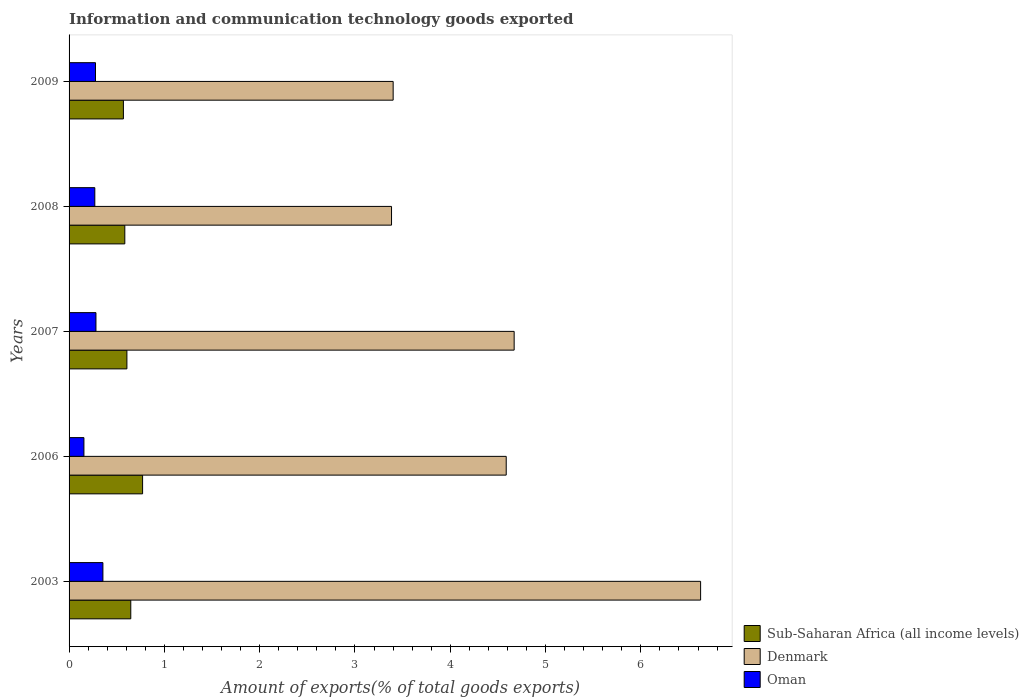How many groups of bars are there?
Provide a short and direct response. 5. How many bars are there on the 5th tick from the top?
Provide a succinct answer. 3. In how many cases, is the number of bars for a given year not equal to the number of legend labels?
Provide a succinct answer. 0. What is the amount of goods exported in Oman in 2006?
Keep it short and to the point. 0.16. Across all years, what is the maximum amount of goods exported in Oman?
Provide a succinct answer. 0.36. Across all years, what is the minimum amount of goods exported in Denmark?
Provide a short and direct response. 3.38. In which year was the amount of goods exported in Denmark minimum?
Offer a very short reply. 2008. What is the total amount of goods exported in Denmark in the graph?
Offer a very short reply. 22.67. What is the difference between the amount of goods exported in Oman in 2006 and that in 2008?
Your response must be concise. -0.11. What is the difference between the amount of goods exported in Sub-Saharan Africa (all income levels) in 2006 and the amount of goods exported in Oman in 2007?
Provide a succinct answer. 0.49. What is the average amount of goods exported in Denmark per year?
Keep it short and to the point. 4.53. In the year 2009, what is the difference between the amount of goods exported in Denmark and amount of goods exported in Sub-Saharan Africa (all income levels)?
Keep it short and to the point. 2.83. What is the ratio of the amount of goods exported in Sub-Saharan Africa (all income levels) in 2007 to that in 2008?
Provide a short and direct response. 1.04. Is the difference between the amount of goods exported in Denmark in 2003 and 2008 greater than the difference between the amount of goods exported in Sub-Saharan Africa (all income levels) in 2003 and 2008?
Ensure brevity in your answer.  Yes. What is the difference between the highest and the second highest amount of goods exported in Denmark?
Offer a very short reply. 1.96. What is the difference between the highest and the lowest amount of goods exported in Denmark?
Offer a very short reply. 3.24. In how many years, is the amount of goods exported in Oman greater than the average amount of goods exported in Oman taken over all years?
Keep it short and to the point. 4. Is the sum of the amount of goods exported in Oman in 2003 and 2007 greater than the maximum amount of goods exported in Denmark across all years?
Give a very brief answer. No. What does the 3rd bar from the top in 2007 represents?
Your response must be concise. Sub-Saharan Africa (all income levels). What does the 1st bar from the bottom in 2006 represents?
Your answer should be very brief. Sub-Saharan Africa (all income levels). Is it the case that in every year, the sum of the amount of goods exported in Oman and amount of goods exported in Denmark is greater than the amount of goods exported in Sub-Saharan Africa (all income levels)?
Your answer should be very brief. Yes. Are all the bars in the graph horizontal?
Make the answer very short. Yes. How many years are there in the graph?
Make the answer very short. 5. What is the difference between two consecutive major ticks on the X-axis?
Make the answer very short. 1. Does the graph contain grids?
Keep it short and to the point. No. What is the title of the graph?
Make the answer very short. Information and communication technology goods exported. What is the label or title of the X-axis?
Make the answer very short. Amount of exports(% of total goods exports). What is the Amount of exports(% of total goods exports) in Sub-Saharan Africa (all income levels) in 2003?
Your answer should be compact. 0.65. What is the Amount of exports(% of total goods exports) in Denmark in 2003?
Your answer should be very brief. 6.63. What is the Amount of exports(% of total goods exports) of Oman in 2003?
Your answer should be compact. 0.36. What is the Amount of exports(% of total goods exports) of Sub-Saharan Africa (all income levels) in 2006?
Keep it short and to the point. 0.77. What is the Amount of exports(% of total goods exports) in Denmark in 2006?
Your answer should be compact. 4.59. What is the Amount of exports(% of total goods exports) in Oman in 2006?
Your answer should be very brief. 0.16. What is the Amount of exports(% of total goods exports) in Sub-Saharan Africa (all income levels) in 2007?
Make the answer very short. 0.61. What is the Amount of exports(% of total goods exports) of Denmark in 2007?
Your answer should be compact. 4.67. What is the Amount of exports(% of total goods exports) in Oman in 2007?
Keep it short and to the point. 0.28. What is the Amount of exports(% of total goods exports) of Sub-Saharan Africa (all income levels) in 2008?
Provide a short and direct response. 0.58. What is the Amount of exports(% of total goods exports) in Denmark in 2008?
Keep it short and to the point. 3.38. What is the Amount of exports(% of total goods exports) in Oman in 2008?
Offer a terse response. 0.27. What is the Amount of exports(% of total goods exports) of Sub-Saharan Africa (all income levels) in 2009?
Your answer should be compact. 0.57. What is the Amount of exports(% of total goods exports) of Denmark in 2009?
Offer a terse response. 3.4. What is the Amount of exports(% of total goods exports) of Oman in 2009?
Keep it short and to the point. 0.28. Across all years, what is the maximum Amount of exports(% of total goods exports) of Sub-Saharan Africa (all income levels)?
Your answer should be compact. 0.77. Across all years, what is the maximum Amount of exports(% of total goods exports) of Denmark?
Your answer should be compact. 6.63. Across all years, what is the maximum Amount of exports(% of total goods exports) in Oman?
Make the answer very short. 0.36. Across all years, what is the minimum Amount of exports(% of total goods exports) of Sub-Saharan Africa (all income levels)?
Ensure brevity in your answer.  0.57. Across all years, what is the minimum Amount of exports(% of total goods exports) in Denmark?
Make the answer very short. 3.38. Across all years, what is the minimum Amount of exports(% of total goods exports) of Oman?
Offer a very short reply. 0.16. What is the total Amount of exports(% of total goods exports) of Sub-Saharan Africa (all income levels) in the graph?
Offer a terse response. 3.18. What is the total Amount of exports(% of total goods exports) in Denmark in the graph?
Your answer should be very brief. 22.67. What is the total Amount of exports(% of total goods exports) of Oman in the graph?
Make the answer very short. 1.34. What is the difference between the Amount of exports(% of total goods exports) of Sub-Saharan Africa (all income levels) in 2003 and that in 2006?
Your response must be concise. -0.12. What is the difference between the Amount of exports(% of total goods exports) in Denmark in 2003 and that in 2006?
Offer a very short reply. 2.04. What is the difference between the Amount of exports(% of total goods exports) of Oman in 2003 and that in 2006?
Ensure brevity in your answer.  0.2. What is the difference between the Amount of exports(% of total goods exports) in Sub-Saharan Africa (all income levels) in 2003 and that in 2007?
Your response must be concise. 0.04. What is the difference between the Amount of exports(% of total goods exports) in Denmark in 2003 and that in 2007?
Provide a short and direct response. 1.96. What is the difference between the Amount of exports(% of total goods exports) in Oman in 2003 and that in 2007?
Your answer should be compact. 0.07. What is the difference between the Amount of exports(% of total goods exports) of Sub-Saharan Africa (all income levels) in 2003 and that in 2008?
Ensure brevity in your answer.  0.06. What is the difference between the Amount of exports(% of total goods exports) of Denmark in 2003 and that in 2008?
Provide a short and direct response. 3.24. What is the difference between the Amount of exports(% of total goods exports) of Oman in 2003 and that in 2008?
Ensure brevity in your answer.  0.08. What is the difference between the Amount of exports(% of total goods exports) in Sub-Saharan Africa (all income levels) in 2003 and that in 2009?
Make the answer very short. 0.08. What is the difference between the Amount of exports(% of total goods exports) of Denmark in 2003 and that in 2009?
Your answer should be compact. 3.23. What is the difference between the Amount of exports(% of total goods exports) of Oman in 2003 and that in 2009?
Your response must be concise. 0.08. What is the difference between the Amount of exports(% of total goods exports) of Sub-Saharan Africa (all income levels) in 2006 and that in 2007?
Provide a short and direct response. 0.16. What is the difference between the Amount of exports(% of total goods exports) in Denmark in 2006 and that in 2007?
Offer a terse response. -0.08. What is the difference between the Amount of exports(% of total goods exports) of Oman in 2006 and that in 2007?
Provide a short and direct response. -0.13. What is the difference between the Amount of exports(% of total goods exports) of Sub-Saharan Africa (all income levels) in 2006 and that in 2008?
Ensure brevity in your answer.  0.19. What is the difference between the Amount of exports(% of total goods exports) in Denmark in 2006 and that in 2008?
Make the answer very short. 1.2. What is the difference between the Amount of exports(% of total goods exports) in Oman in 2006 and that in 2008?
Provide a short and direct response. -0.11. What is the difference between the Amount of exports(% of total goods exports) in Sub-Saharan Africa (all income levels) in 2006 and that in 2009?
Ensure brevity in your answer.  0.2. What is the difference between the Amount of exports(% of total goods exports) of Denmark in 2006 and that in 2009?
Offer a very short reply. 1.19. What is the difference between the Amount of exports(% of total goods exports) in Oman in 2006 and that in 2009?
Your response must be concise. -0.12. What is the difference between the Amount of exports(% of total goods exports) of Sub-Saharan Africa (all income levels) in 2007 and that in 2008?
Offer a terse response. 0.02. What is the difference between the Amount of exports(% of total goods exports) of Denmark in 2007 and that in 2008?
Ensure brevity in your answer.  1.29. What is the difference between the Amount of exports(% of total goods exports) of Oman in 2007 and that in 2008?
Keep it short and to the point. 0.01. What is the difference between the Amount of exports(% of total goods exports) in Sub-Saharan Africa (all income levels) in 2007 and that in 2009?
Your response must be concise. 0.04. What is the difference between the Amount of exports(% of total goods exports) in Denmark in 2007 and that in 2009?
Make the answer very short. 1.27. What is the difference between the Amount of exports(% of total goods exports) in Oman in 2007 and that in 2009?
Your answer should be very brief. 0. What is the difference between the Amount of exports(% of total goods exports) of Sub-Saharan Africa (all income levels) in 2008 and that in 2009?
Ensure brevity in your answer.  0.01. What is the difference between the Amount of exports(% of total goods exports) in Denmark in 2008 and that in 2009?
Provide a succinct answer. -0.02. What is the difference between the Amount of exports(% of total goods exports) in Oman in 2008 and that in 2009?
Keep it short and to the point. -0.01. What is the difference between the Amount of exports(% of total goods exports) of Sub-Saharan Africa (all income levels) in 2003 and the Amount of exports(% of total goods exports) of Denmark in 2006?
Your answer should be compact. -3.94. What is the difference between the Amount of exports(% of total goods exports) in Sub-Saharan Africa (all income levels) in 2003 and the Amount of exports(% of total goods exports) in Oman in 2006?
Keep it short and to the point. 0.49. What is the difference between the Amount of exports(% of total goods exports) in Denmark in 2003 and the Amount of exports(% of total goods exports) in Oman in 2006?
Offer a terse response. 6.47. What is the difference between the Amount of exports(% of total goods exports) in Sub-Saharan Africa (all income levels) in 2003 and the Amount of exports(% of total goods exports) in Denmark in 2007?
Your answer should be compact. -4.02. What is the difference between the Amount of exports(% of total goods exports) of Sub-Saharan Africa (all income levels) in 2003 and the Amount of exports(% of total goods exports) of Oman in 2007?
Provide a succinct answer. 0.37. What is the difference between the Amount of exports(% of total goods exports) in Denmark in 2003 and the Amount of exports(% of total goods exports) in Oman in 2007?
Offer a very short reply. 6.34. What is the difference between the Amount of exports(% of total goods exports) of Sub-Saharan Africa (all income levels) in 2003 and the Amount of exports(% of total goods exports) of Denmark in 2008?
Provide a succinct answer. -2.74. What is the difference between the Amount of exports(% of total goods exports) in Sub-Saharan Africa (all income levels) in 2003 and the Amount of exports(% of total goods exports) in Oman in 2008?
Your answer should be very brief. 0.38. What is the difference between the Amount of exports(% of total goods exports) of Denmark in 2003 and the Amount of exports(% of total goods exports) of Oman in 2008?
Ensure brevity in your answer.  6.36. What is the difference between the Amount of exports(% of total goods exports) of Sub-Saharan Africa (all income levels) in 2003 and the Amount of exports(% of total goods exports) of Denmark in 2009?
Your response must be concise. -2.75. What is the difference between the Amount of exports(% of total goods exports) in Sub-Saharan Africa (all income levels) in 2003 and the Amount of exports(% of total goods exports) in Oman in 2009?
Provide a succinct answer. 0.37. What is the difference between the Amount of exports(% of total goods exports) of Denmark in 2003 and the Amount of exports(% of total goods exports) of Oman in 2009?
Offer a terse response. 6.35. What is the difference between the Amount of exports(% of total goods exports) of Sub-Saharan Africa (all income levels) in 2006 and the Amount of exports(% of total goods exports) of Denmark in 2007?
Your answer should be compact. -3.9. What is the difference between the Amount of exports(% of total goods exports) of Sub-Saharan Africa (all income levels) in 2006 and the Amount of exports(% of total goods exports) of Oman in 2007?
Provide a short and direct response. 0.49. What is the difference between the Amount of exports(% of total goods exports) of Denmark in 2006 and the Amount of exports(% of total goods exports) of Oman in 2007?
Provide a short and direct response. 4.31. What is the difference between the Amount of exports(% of total goods exports) in Sub-Saharan Africa (all income levels) in 2006 and the Amount of exports(% of total goods exports) in Denmark in 2008?
Your answer should be very brief. -2.61. What is the difference between the Amount of exports(% of total goods exports) in Sub-Saharan Africa (all income levels) in 2006 and the Amount of exports(% of total goods exports) in Oman in 2008?
Your response must be concise. 0.5. What is the difference between the Amount of exports(% of total goods exports) in Denmark in 2006 and the Amount of exports(% of total goods exports) in Oman in 2008?
Give a very brief answer. 4.32. What is the difference between the Amount of exports(% of total goods exports) of Sub-Saharan Africa (all income levels) in 2006 and the Amount of exports(% of total goods exports) of Denmark in 2009?
Ensure brevity in your answer.  -2.63. What is the difference between the Amount of exports(% of total goods exports) in Sub-Saharan Africa (all income levels) in 2006 and the Amount of exports(% of total goods exports) in Oman in 2009?
Your answer should be compact. 0.49. What is the difference between the Amount of exports(% of total goods exports) in Denmark in 2006 and the Amount of exports(% of total goods exports) in Oman in 2009?
Ensure brevity in your answer.  4.31. What is the difference between the Amount of exports(% of total goods exports) in Sub-Saharan Africa (all income levels) in 2007 and the Amount of exports(% of total goods exports) in Denmark in 2008?
Provide a short and direct response. -2.78. What is the difference between the Amount of exports(% of total goods exports) of Sub-Saharan Africa (all income levels) in 2007 and the Amount of exports(% of total goods exports) of Oman in 2008?
Keep it short and to the point. 0.34. What is the difference between the Amount of exports(% of total goods exports) in Denmark in 2007 and the Amount of exports(% of total goods exports) in Oman in 2008?
Ensure brevity in your answer.  4.4. What is the difference between the Amount of exports(% of total goods exports) in Sub-Saharan Africa (all income levels) in 2007 and the Amount of exports(% of total goods exports) in Denmark in 2009?
Ensure brevity in your answer.  -2.79. What is the difference between the Amount of exports(% of total goods exports) of Sub-Saharan Africa (all income levels) in 2007 and the Amount of exports(% of total goods exports) of Oman in 2009?
Provide a succinct answer. 0.33. What is the difference between the Amount of exports(% of total goods exports) of Denmark in 2007 and the Amount of exports(% of total goods exports) of Oman in 2009?
Offer a very short reply. 4.39. What is the difference between the Amount of exports(% of total goods exports) in Sub-Saharan Africa (all income levels) in 2008 and the Amount of exports(% of total goods exports) in Denmark in 2009?
Offer a terse response. -2.82. What is the difference between the Amount of exports(% of total goods exports) in Sub-Saharan Africa (all income levels) in 2008 and the Amount of exports(% of total goods exports) in Oman in 2009?
Offer a very short reply. 0.31. What is the difference between the Amount of exports(% of total goods exports) in Denmark in 2008 and the Amount of exports(% of total goods exports) in Oman in 2009?
Make the answer very short. 3.11. What is the average Amount of exports(% of total goods exports) of Sub-Saharan Africa (all income levels) per year?
Offer a very short reply. 0.64. What is the average Amount of exports(% of total goods exports) in Denmark per year?
Make the answer very short. 4.53. What is the average Amount of exports(% of total goods exports) in Oman per year?
Your response must be concise. 0.27. In the year 2003, what is the difference between the Amount of exports(% of total goods exports) of Sub-Saharan Africa (all income levels) and Amount of exports(% of total goods exports) of Denmark?
Give a very brief answer. -5.98. In the year 2003, what is the difference between the Amount of exports(% of total goods exports) of Sub-Saharan Africa (all income levels) and Amount of exports(% of total goods exports) of Oman?
Give a very brief answer. 0.29. In the year 2003, what is the difference between the Amount of exports(% of total goods exports) in Denmark and Amount of exports(% of total goods exports) in Oman?
Give a very brief answer. 6.27. In the year 2006, what is the difference between the Amount of exports(% of total goods exports) in Sub-Saharan Africa (all income levels) and Amount of exports(% of total goods exports) in Denmark?
Offer a terse response. -3.82. In the year 2006, what is the difference between the Amount of exports(% of total goods exports) of Sub-Saharan Africa (all income levels) and Amount of exports(% of total goods exports) of Oman?
Ensure brevity in your answer.  0.62. In the year 2006, what is the difference between the Amount of exports(% of total goods exports) of Denmark and Amount of exports(% of total goods exports) of Oman?
Provide a succinct answer. 4.43. In the year 2007, what is the difference between the Amount of exports(% of total goods exports) of Sub-Saharan Africa (all income levels) and Amount of exports(% of total goods exports) of Denmark?
Give a very brief answer. -4.06. In the year 2007, what is the difference between the Amount of exports(% of total goods exports) in Sub-Saharan Africa (all income levels) and Amount of exports(% of total goods exports) in Oman?
Your response must be concise. 0.32. In the year 2007, what is the difference between the Amount of exports(% of total goods exports) in Denmark and Amount of exports(% of total goods exports) in Oman?
Make the answer very short. 4.39. In the year 2008, what is the difference between the Amount of exports(% of total goods exports) in Sub-Saharan Africa (all income levels) and Amount of exports(% of total goods exports) in Denmark?
Make the answer very short. -2.8. In the year 2008, what is the difference between the Amount of exports(% of total goods exports) of Sub-Saharan Africa (all income levels) and Amount of exports(% of total goods exports) of Oman?
Keep it short and to the point. 0.31. In the year 2008, what is the difference between the Amount of exports(% of total goods exports) of Denmark and Amount of exports(% of total goods exports) of Oman?
Provide a succinct answer. 3.11. In the year 2009, what is the difference between the Amount of exports(% of total goods exports) in Sub-Saharan Africa (all income levels) and Amount of exports(% of total goods exports) in Denmark?
Your response must be concise. -2.83. In the year 2009, what is the difference between the Amount of exports(% of total goods exports) of Sub-Saharan Africa (all income levels) and Amount of exports(% of total goods exports) of Oman?
Your response must be concise. 0.29. In the year 2009, what is the difference between the Amount of exports(% of total goods exports) in Denmark and Amount of exports(% of total goods exports) in Oman?
Ensure brevity in your answer.  3.12. What is the ratio of the Amount of exports(% of total goods exports) in Sub-Saharan Africa (all income levels) in 2003 to that in 2006?
Ensure brevity in your answer.  0.84. What is the ratio of the Amount of exports(% of total goods exports) of Denmark in 2003 to that in 2006?
Your response must be concise. 1.44. What is the ratio of the Amount of exports(% of total goods exports) of Oman in 2003 to that in 2006?
Your answer should be compact. 2.28. What is the ratio of the Amount of exports(% of total goods exports) of Sub-Saharan Africa (all income levels) in 2003 to that in 2007?
Your answer should be compact. 1.07. What is the ratio of the Amount of exports(% of total goods exports) of Denmark in 2003 to that in 2007?
Your answer should be very brief. 1.42. What is the ratio of the Amount of exports(% of total goods exports) in Oman in 2003 to that in 2007?
Provide a succinct answer. 1.26. What is the ratio of the Amount of exports(% of total goods exports) in Sub-Saharan Africa (all income levels) in 2003 to that in 2008?
Ensure brevity in your answer.  1.11. What is the ratio of the Amount of exports(% of total goods exports) of Denmark in 2003 to that in 2008?
Your answer should be very brief. 1.96. What is the ratio of the Amount of exports(% of total goods exports) of Oman in 2003 to that in 2008?
Your response must be concise. 1.31. What is the ratio of the Amount of exports(% of total goods exports) in Sub-Saharan Africa (all income levels) in 2003 to that in 2009?
Your answer should be compact. 1.14. What is the ratio of the Amount of exports(% of total goods exports) of Denmark in 2003 to that in 2009?
Offer a terse response. 1.95. What is the ratio of the Amount of exports(% of total goods exports) of Oman in 2003 to that in 2009?
Provide a short and direct response. 1.28. What is the ratio of the Amount of exports(% of total goods exports) in Sub-Saharan Africa (all income levels) in 2006 to that in 2007?
Offer a terse response. 1.27. What is the ratio of the Amount of exports(% of total goods exports) in Denmark in 2006 to that in 2007?
Offer a terse response. 0.98. What is the ratio of the Amount of exports(% of total goods exports) of Oman in 2006 to that in 2007?
Provide a short and direct response. 0.55. What is the ratio of the Amount of exports(% of total goods exports) in Sub-Saharan Africa (all income levels) in 2006 to that in 2008?
Provide a short and direct response. 1.32. What is the ratio of the Amount of exports(% of total goods exports) in Denmark in 2006 to that in 2008?
Give a very brief answer. 1.36. What is the ratio of the Amount of exports(% of total goods exports) in Oman in 2006 to that in 2008?
Offer a very short reply. 0.58. What is the ratio of the Amount of exports(% of total goods exports) of Sub-Saharan Africa (all income levels) in 2006 to that in 2009?
Make the answer very short. 1.35. What is the ratio of the Amount of exports(% of total goods exports) in Denmark in 2006 to that in 2009?
Keep it short and to the point. 1.35. What is the ratio of the Amount of exports(% of total goods exports) in Oman in 2006 to that in 2009?
Your answer should be very brief. 0.56. What is the ratio of the Amount of exports(% of total goods exports) of Sub-Saharan Africa (all income levels) in 2007 to that in 2008?
Offer a terse response. 1.04. What is the ratio of the Amount of exports(% of total goods exports) of Denmark in 2007 to that in 2008?
Provide a short and direct response. 1.38. What is the ratio of the Amount of exports(% of total goods exports) in Oman in 2007 to that in 2008?
Offer a terse response. 1.04. What is the ratio of the Amount of exports(% of total goods exports) of Sub-Saharan Africa (all income levels) in 2007 to that in 2009?
Ensure brevity in your answer.  1.06. What is the ratio of the Amount of exports(% of total goods exports) of Denmark in 2007 to that in 2009?
Your response must be concise. 1.37. What is the ratio of the Amount of exports(% of total goods exports) of Oman in 2007 to that in 2009?
Offer a terse response. 1.02. What is the ratio of the Amount of exports(% of total goods exports) of Sub-Saharan Africa (all income levels) in 2008 to that in 2009?
Ensure brevity in your answer.  1.03. What is the ratio of the Amount of exports(% of total goods exports) in Denmark in 2008 to that in 2009?
Keep it short and to the point. 0.99. What is the ratio of the Amount of exports(% of total goods exports) of Oman in 2008 to that in 2009?
Ensure brevity in your answer.  0.97. What is the difference between the highest and the second highest Amount of exports(% of total goods exports) of Sub-Saharan Africa (all income levels)?
Give a very brief answer. 0.12. What is the difference between the highest and the second highest Amount of exports(% of total goods exports) of Denmark?
Provide a short and direct response. 1.96. What is the difference between the highest and the second highest Amount of exports(% of total goods exports) of Oman?
Your response must be concise. 0.07. What is the difference between the highest and the lowest Amount of exports(% of total goods exports) of Sub-Saharan Africa (all income levels)?
Offer a terse response. 0.2. What is the difference between the highest and the lowest Amount of exports(% of total goods exports) in Denmark?
Your answer should be very brief. 3.24. What is the difference between the highest and the lowest Amount of exports(% of total goods exports) of Oman?
Keep it short and to the point. 0.2. 